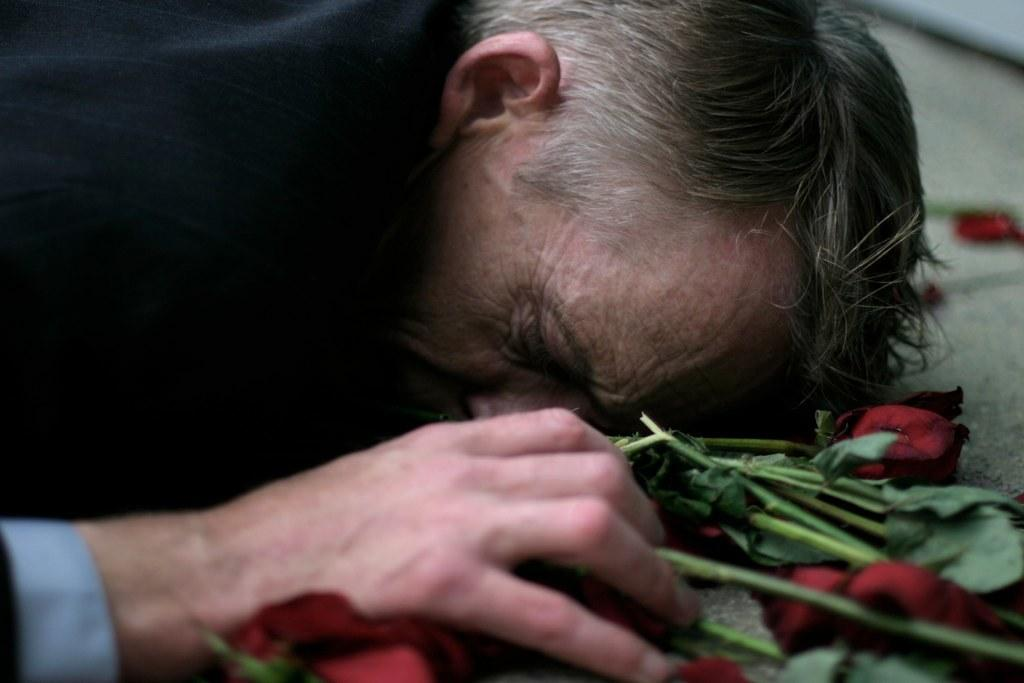Who is present in the image? There is a man in the image. What is the man doing in the image? The man is laying down. What can be seen beside the man in the image? There are roses beside the man. What type of liquid is being poured on the man's knee in the image? There is no liquid being poured on the man's knee in the image; the man is laying down with roses beside him. 